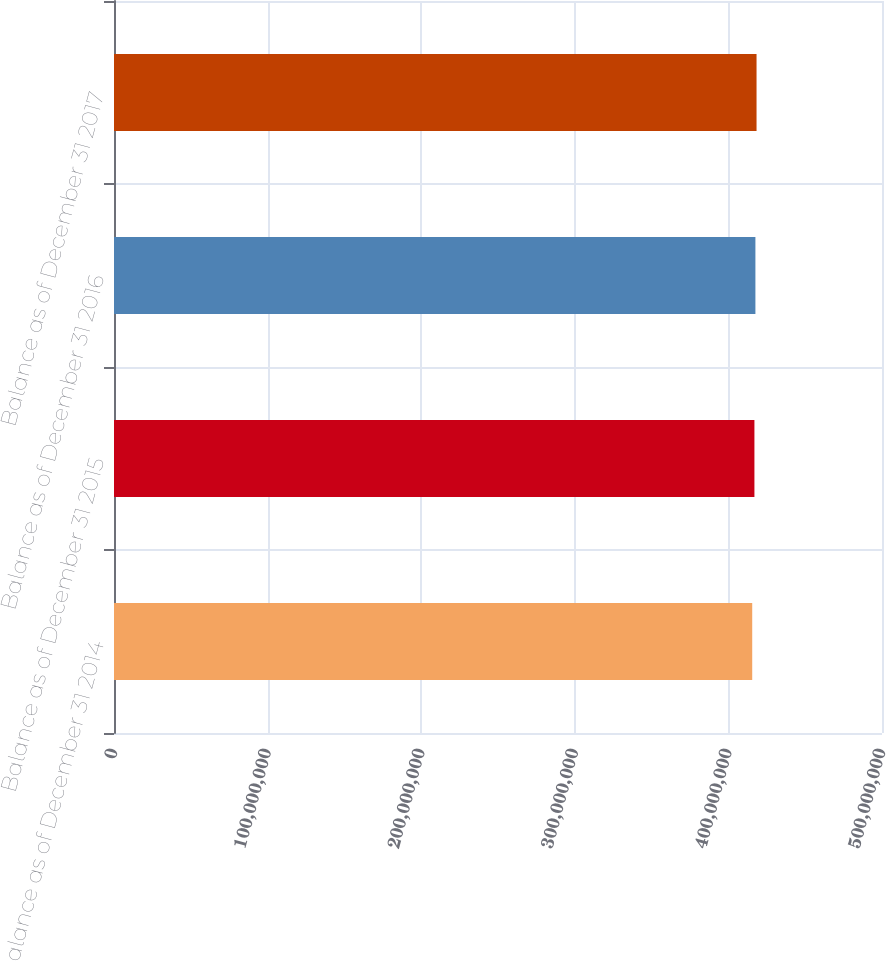Convert chart to OTSL. <chart><loc_0><loc_0><loc_500><loc_500><bar_chart><fcel>Balance as of December 31 2014<fcel>Balance as of December 31 2015<fcel>Balance as of December 31 2016<fcel>Balance as of December 31 2017<nl><fcel>4.15506e+08<fcel>4.1694e+08<fcel>4.17584e+08<fcel>4.18323e+08<nl></chart> 